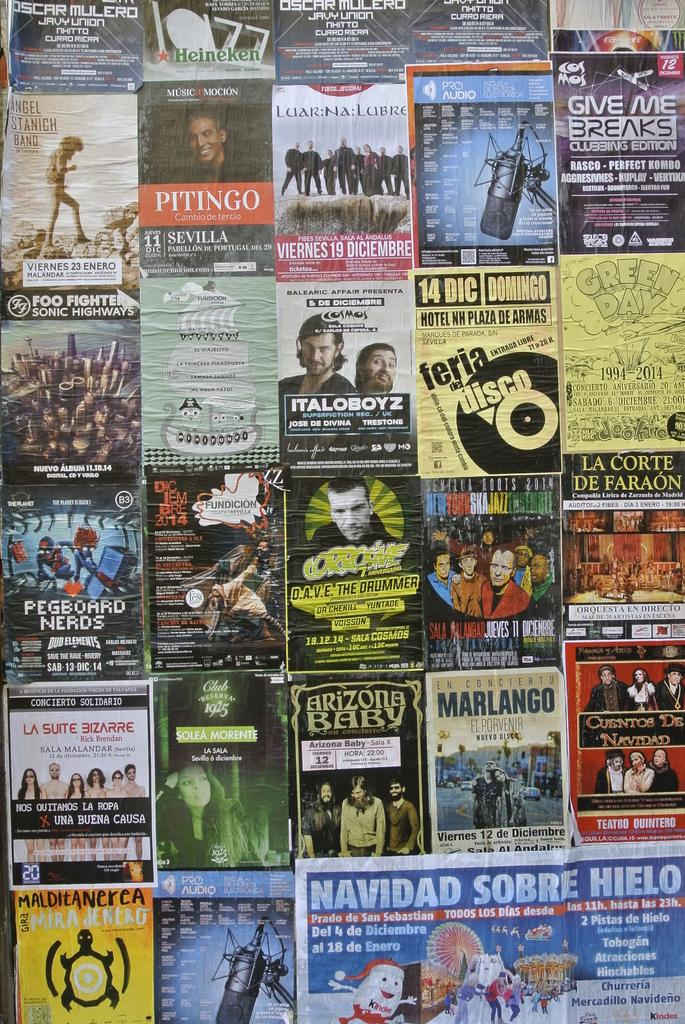<image>
Describe the image concisely. A poster for ITALOBOYZ is displayed on a while among many other posters 